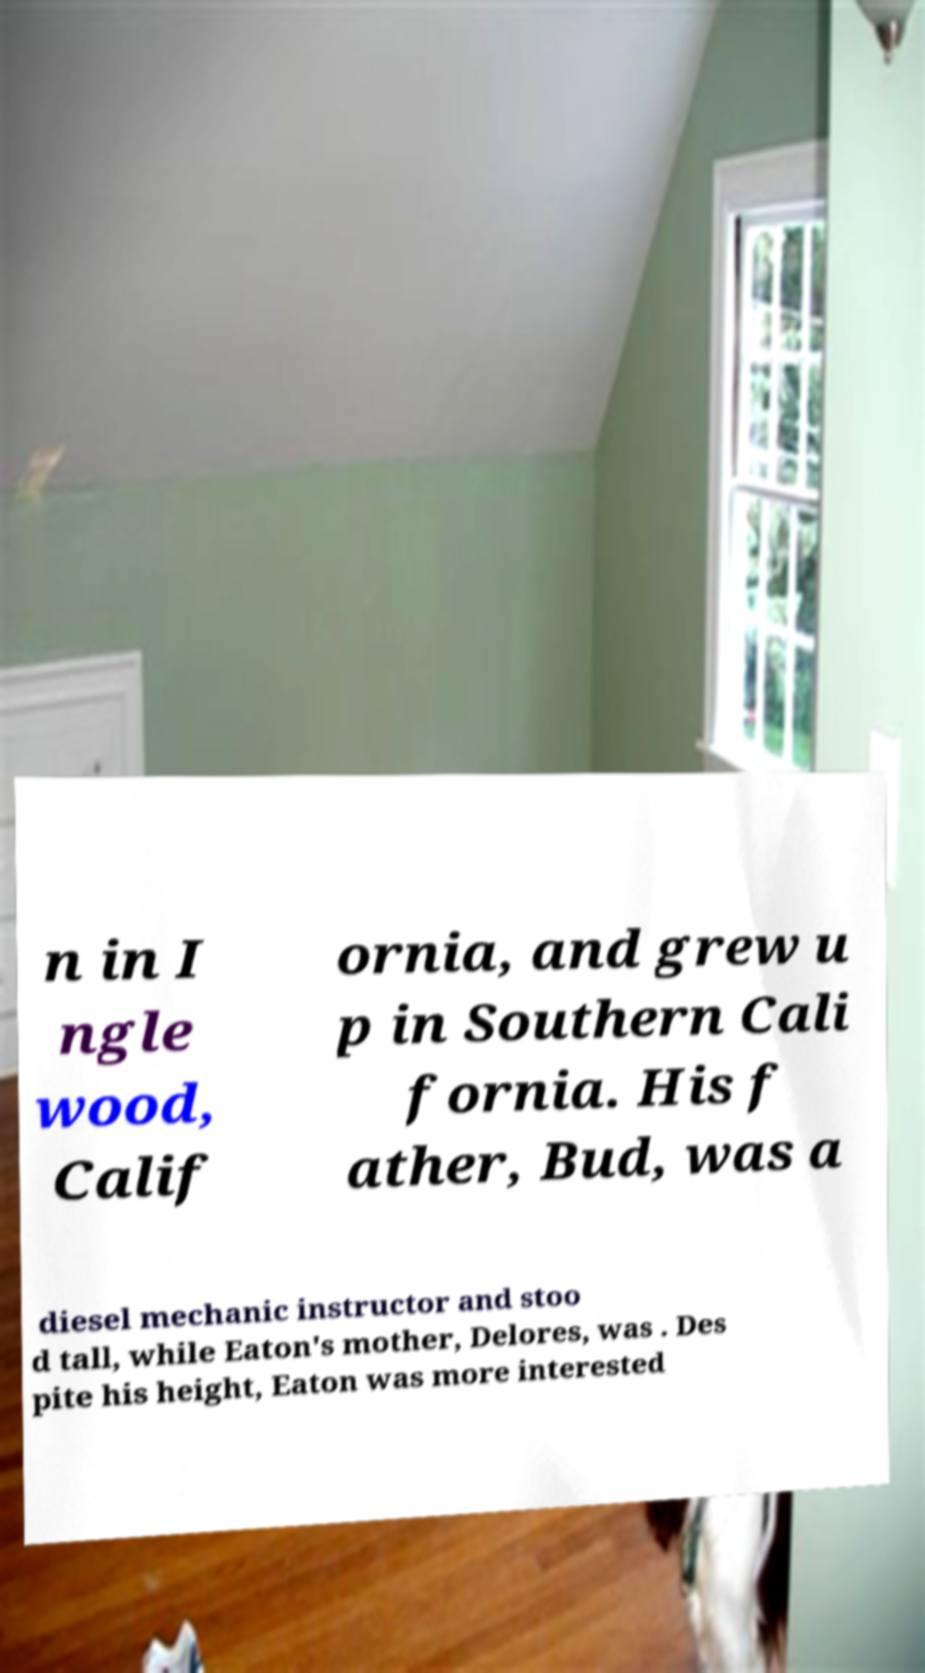What messages or text are displayed in this image? I need them in a readable, typed format. n in I ngle wood, Calif ornia, and grew u p in Southern Cali fornia. His f ather, Bud, was a diesel mechanic instructor and stoo d tall, while Eaton's mother, Delores, was . Des pite his height, Eaton was more interested 